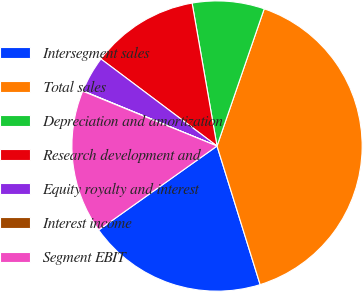Convert chart. <chart><loc_0><loc_0><loc_500><loc_500><pie_chart><fcel>Intersegment sales<fcel>Total sales<fcel>Depreciation and amortization<fcel>Research development and<fcel>Equity royalty and interest<fcel>Interest income<fcel>Segment EBIT<nl><fcel>19.98%<fcel>39.93%<fcel>8.02%<fcel>12.01%<fcel>4.03%<fcel>0.04%<fcel>16.0%<nl></chart> 